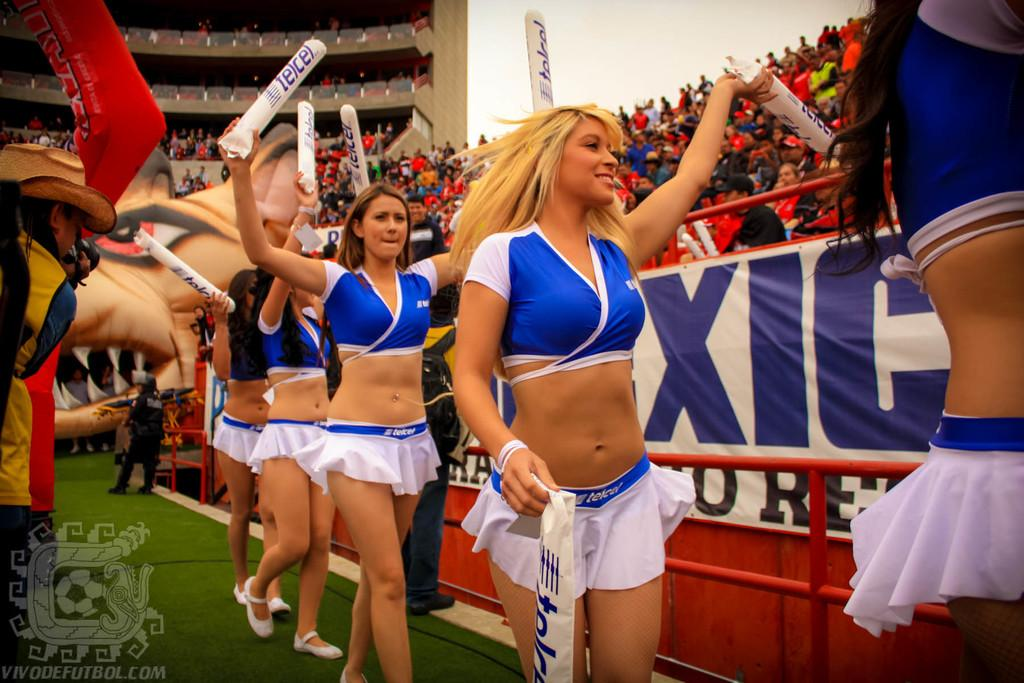<image>
Share a concise interpretation of the image provided. The cheerleaders are carrying batons with the word Telcel on them. 